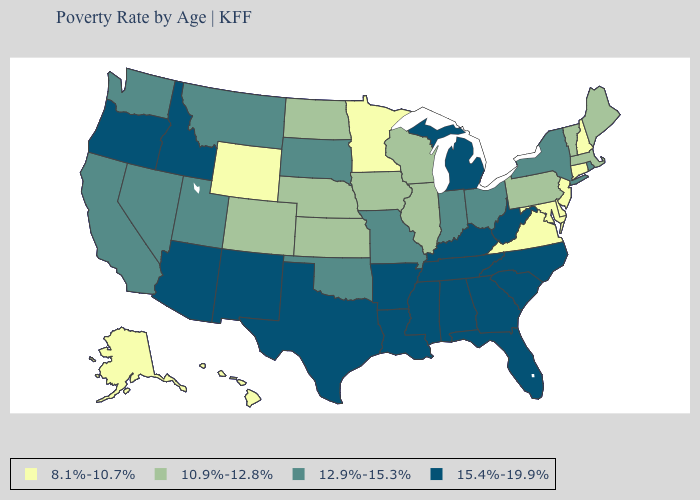Name the states that have a value in the range 15.4%-19.9%?
Short answer required. Alabama, Arizona, Arkansas, Florida, Georgia, Idaho, Kentucky, Louisiana, Michigan, Mississippi, New Mexico, North Carolina, Oregon, South Carolina, Tennessee, Texas, West Virginia. Does Minnesota have the lowest value in the MidWest?
Answer briefly. Yes. Among the states that border Nevada , which have the highest value?
Write a very short answer. Arizona, Idaho, Oregon. Does Louisiana have a lower value than Nevada?
Quick response, please. No. How many symbols are there in the legend?
Concise answer only. 4. Does the first symbol in the legend represent the smallest category?
Be succinct. Yes. Does the map have missing data?
Answer briefly. No. Does Rhode Island have the highest value in the Northeast?
Be succinct. Yes. How many symbols are there in the legend?
Short answer required. 4. Which states have the lowest value in the USA?
Answer briefly. Alaska, Connecticut, Delaware, Hawaii, Maryland, Minnesota, New Hampshire, New Jersey, Virginia, Wyoming. Does Wisconsin have the highest value in the MidWest?
Quick response, please. No. Does Kansas have the lowest value in the MidWest?
Give a very brief answer. No. Name the states that have a value in the range 15.4%-19.9%?
Short answer required. Alabama, Arizona, Arkansas, Florida, Georgia, Idaho, Kentucky, Louisiana, Michigan, Mississippi, New Mexico, North Carolina, Oregon, South Carolina, Tennessee, Texas, West Virginia. Name the states that have a value in the range 10.9%-12.8%?
Write a very short answer. Colorado, Illinois, Iowa, Kansas, Maine, Massachusetts, Nebraska, North Dakota, Pennsylvania, Vermont, Wisconsin. Which states hav the highest value in the West?
Quick response, please. Arizona, Idaho, New Mexico, Oregon. 